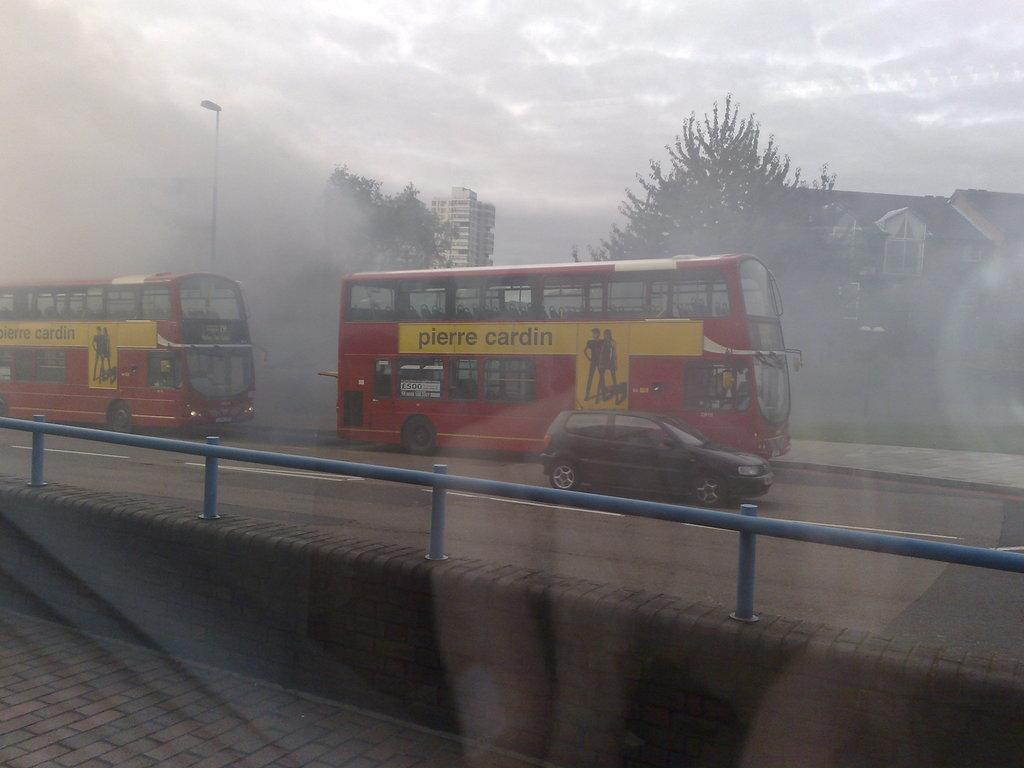<image>
Provide a brief description of the given image. two double decker red buses with ads for Pierre Cardin on the dids 